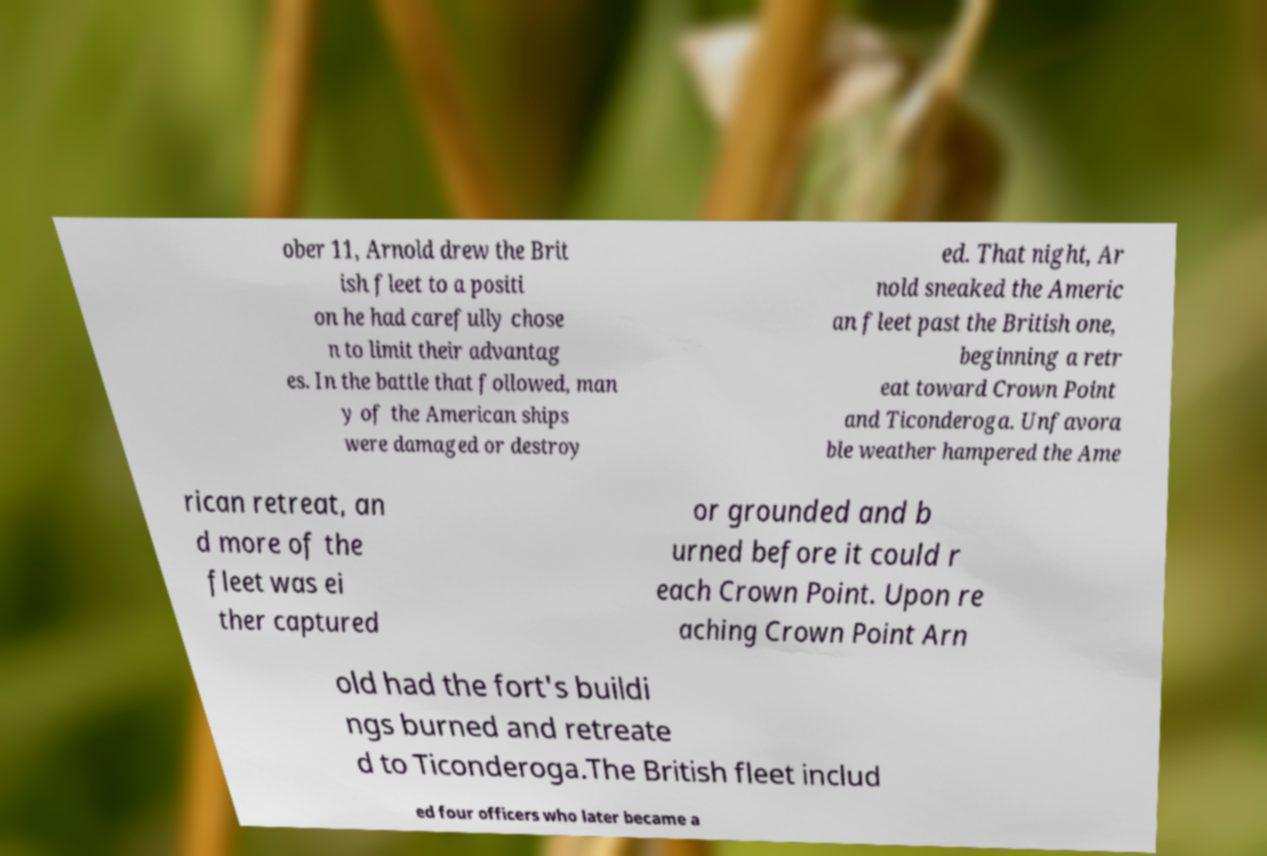Could you extract and type out the text from this image? ober 11, Arnold drew the Brit ish fleet to a positi on he had carefully chose n to limit their advantag es. In the battle that followed, man y of the American ships were damaged or destroy ed. That night, Ar nold sneaked the Americ an fleet past the British one, beginning a retr eat toward Crown Point and Ticonderoga. Unfavora ble weather hampered the Ame rican retreat, an d more of the fleet was ei ther captured or grounded and b urned before it could r each Crown Point. Upon re aching Crown Point Arn old had the fort's buildi ngs burned and retreate d to Ticonderoga.The British fleet includ ed four officers who later became a 